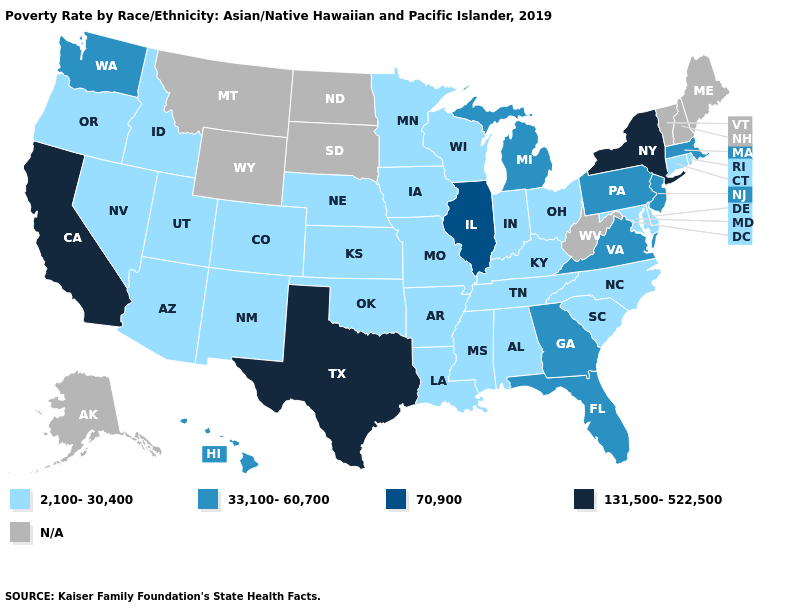Does Virginia have the lowest value in the South?
Write a very short answer. No. How many symbols are there in the legend?
Write a very short answer. 5. Does New York have the lowest value in the USA?
Concise answer only. No. How many symbols are there in the legend?
Keep it brief. 5. Which states hav the highest value in the Northeast?
Give a very brief answer. New York. How many symbols are there in the legend?
Concise answer only. 5. What is the lowest value in states that border Illinois?
Be succinct. 2,100-30,400. Name the states that have a value in the range 131,500-522,500?
Write a very short answer. California, New York, Texas. How many symbols are there in the legend?
Write a very short answer. 5. Does the map have missing data?
Concise answer only. Yes. Does Rhode Island have the highest value in the USA?
Quick response, please. No. Does California have the highest value in the USA?
Keep it brief. Yes. Does California have the highest value in the West?
Write a very short answer. Yes. Name the states that have a value in the range 70,900?
Quick response, please. Illinois. 